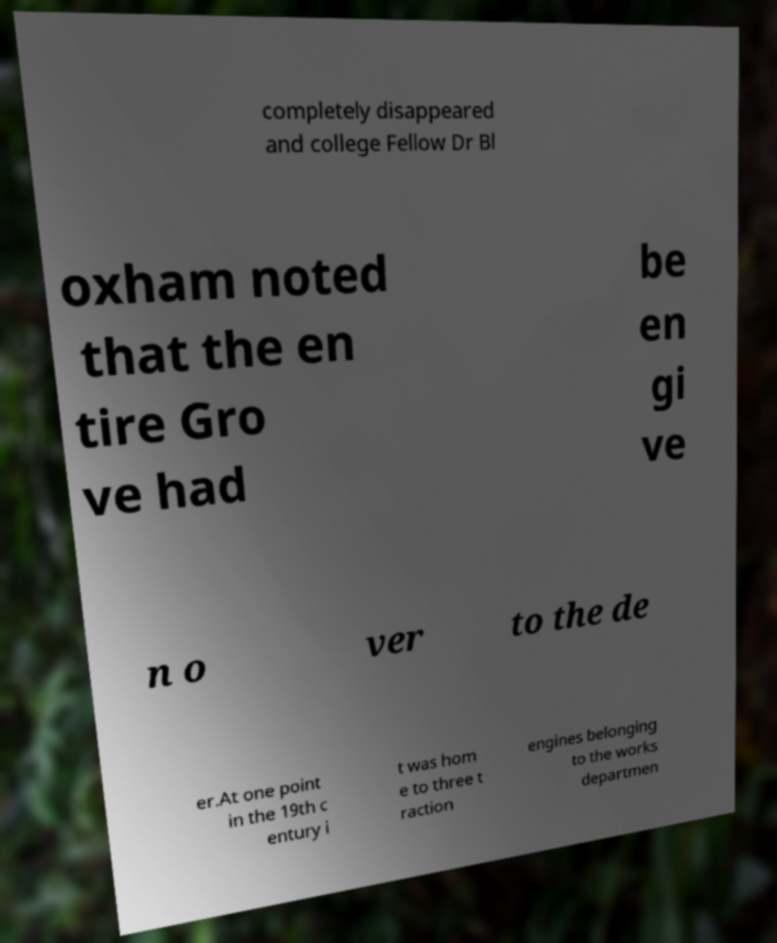For documentation purposes, I need the text within this image transcribed. Could you provide that? completely disappeared and college Fellow Dr Bl oxham noted that the en tire Gro ve had be en gi ve n o ver to the de er.At one point in the 19th c entury i t was hom e to three t raction engines belonging to the works departmen 